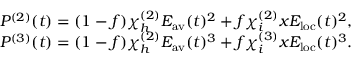<formula> <loc_0><loc_0><loc_500><loc_500>\begin{array} { r } { P ^ { ( 2 ) } ( t ) = ( 1 - f ) \chi _ { h } ^ { ( 2 ) } E _ { a v } ( t ) ^ { 2 } + f \chi _ { i } ^ { ( 2 ) } x E _ { l o c } ( t ) ^ { 2 } , } \\ { P ^ { ( 3 ) } ( t ) = ( 1 - f ) \chi _ { h } ^ { ( 2 ) } E _ { a v } ( t ) ^ { 3 } + f \chi _ { i } ^ { ( 3 ) } x E _ { l o c } ( t ) ^ { 3 } . } \end{array}</formula> 